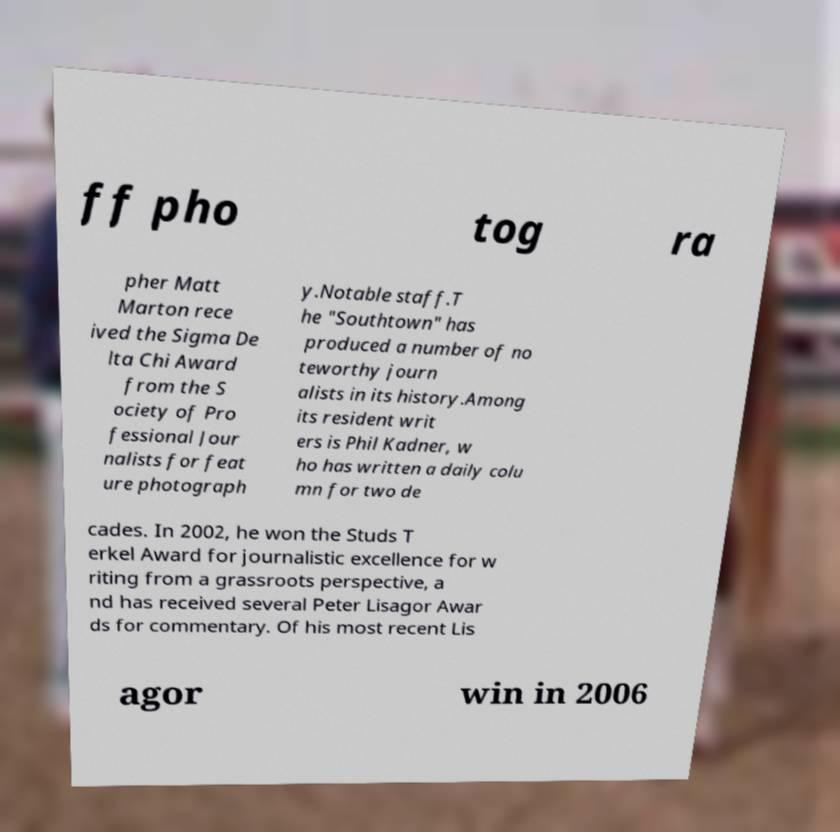Please identify and transcribe the text found in this image. ff pho tog ra pher Matt Marton rece ived the Sigma De lta Chi Award from the S ociety of Pro fessional Jour nalists for feat ure photograph y.Notable staff.T he "Southtown" has produced a number of no teworthy journ alists in its history.Among its resident writ ers is Phil Kadner, w ho has written a daily colu mn for two de cades. In 2002, he won the Studs T erkel Award for journalistic excellence for w riting from a grassroots perspective, a nd has received several Peter Lisagor Awar ds for commentary. Of his most recent Lis agor win in 2006 